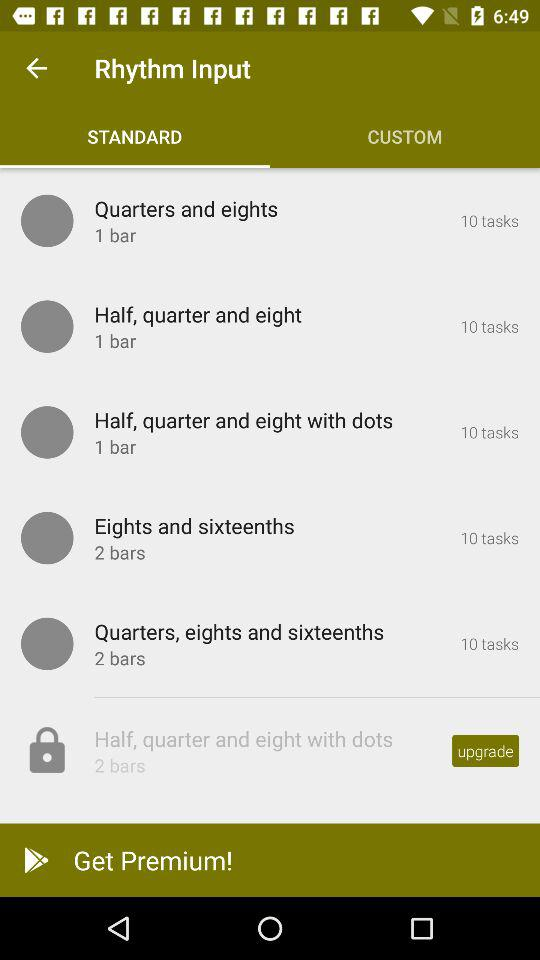What is the number of task in "Half, quarter and eight"? The number of task in "Half, quarter and eight" is 10. 